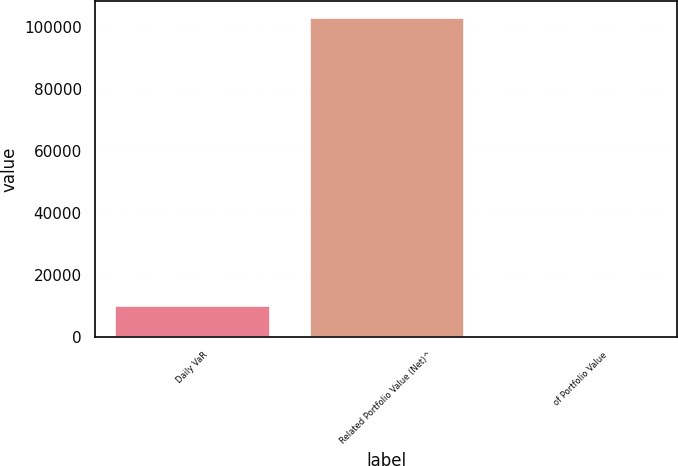Convert chart to OTSL. <chart><loc_0><loc_0><loc_500><loc_500><bar_chart><fcel>Daily VaR<fcel>Related Portfolio Value (Net)^<fcel>of Portfolio Value<nl><fcel>10305.2<fcel>103047<fcel>0.57<nl></chart> 